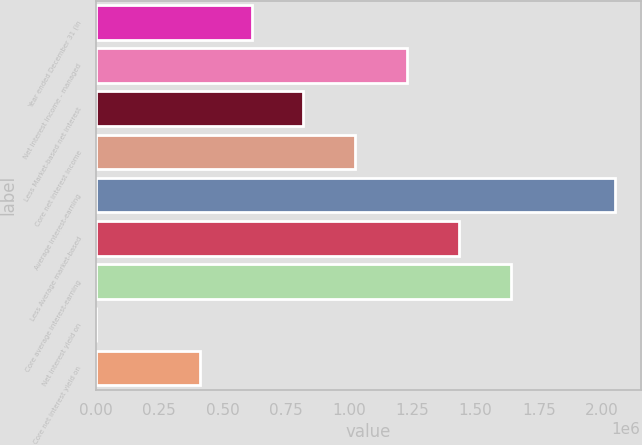Convert chart. <chart><loc_0><loc_0><loc_500><loc_500><bar_chart><fcel>Year ended December 31 (in<fcel>Net interest income - managed<fcel>Less Market-based net interest<fcel>Core net interest income<fcel>Average interest-earning<fcel>Less Average market-based<fcel>Core average interest-earning<fcel>Net interest yield on<fcel>Core net interest yield on<nl><fcel>614729<fcel>1.22946e+06<fcel>819638<fcel>1.02455e+06<fcel>2.04909e+06<fcel>1.43437e+06<fcel>1.63927e+06<fcel>1.09<fcel>409819<nl></chart> 